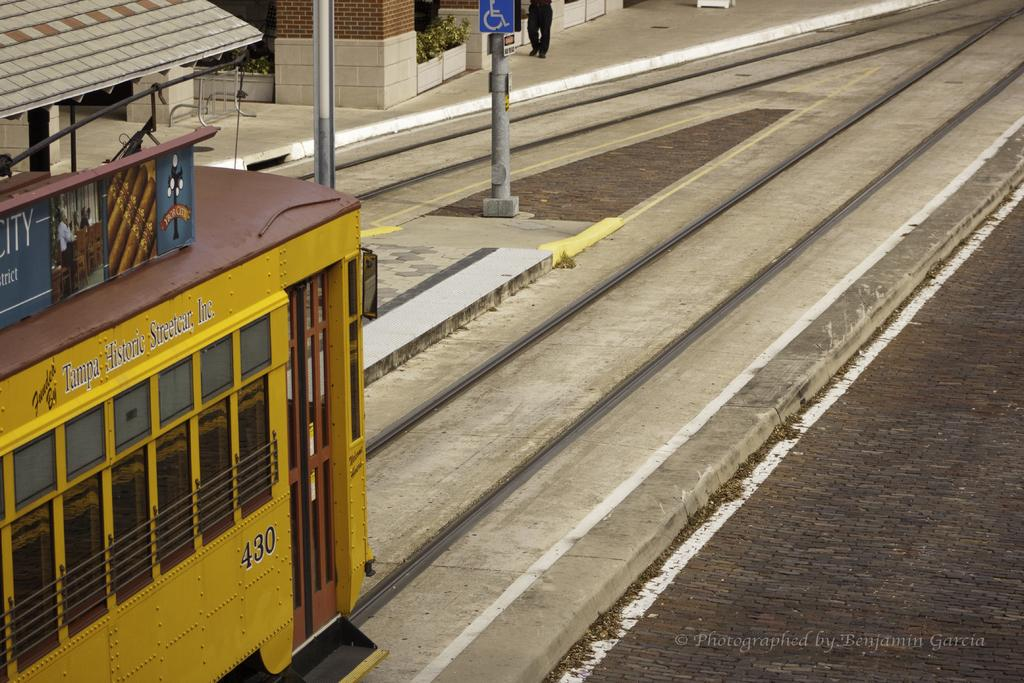What type of vehicle is in the image? There is a yellow color train in the image. Where is the train located? The train is on a railway track. What else can be seen on the right side of the image? There is a road on the right side of the image. What structures are visible at the top of the image? Poles, a shelter, and a wall are visible at the top of the image. How many people are in the image? There is one person in the image. What type of coast can be seen in the image? There is no coast visible in the image; it features a train on a railway track and other structures. What is the purpose of the library in the image? There is no library present in the image. 